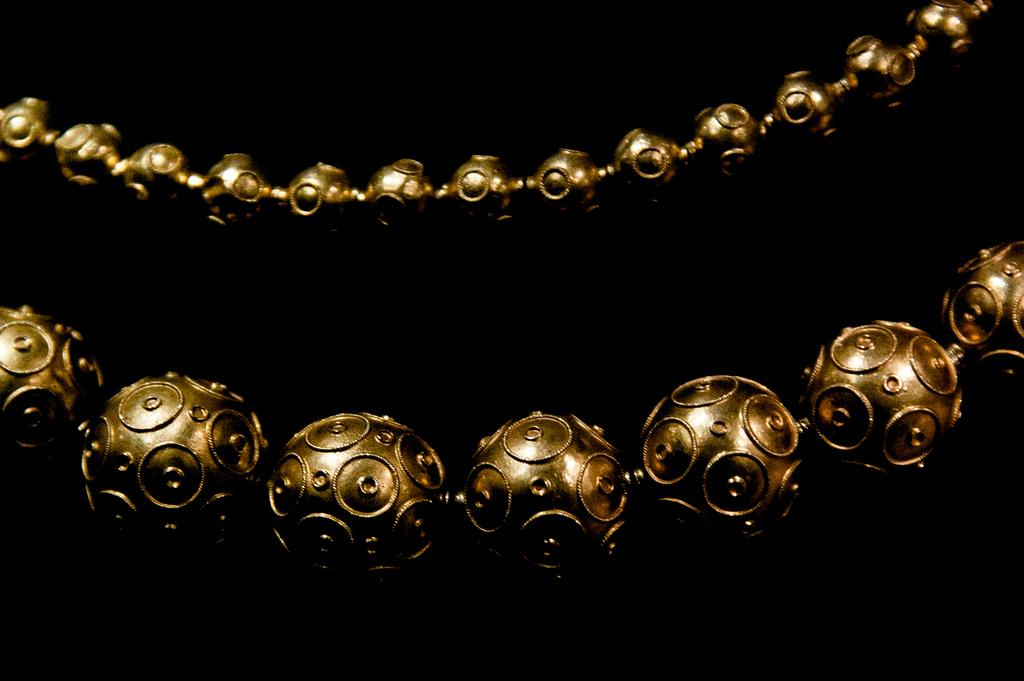What color is the background of the image? The background of the image is black. What can be seen in the middle of the image? There are two chains in the middle of the image. What is the color of the chains? The chains are gold in color. How many lizards can be seen crawling on the chains in the image? There are no lizards present in the image; it only features two gold chains. 